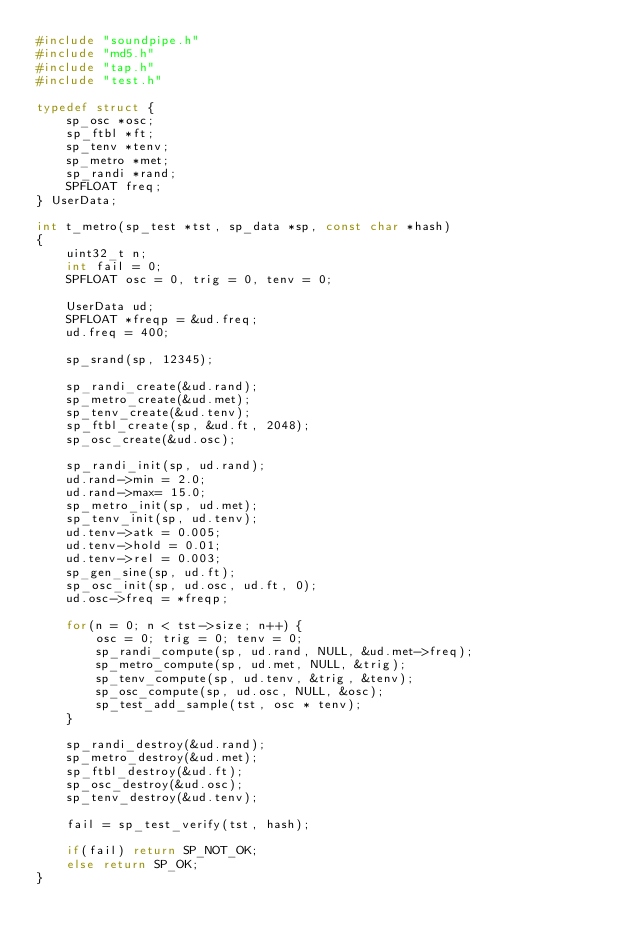<code> <loc_0><loc_0><loc_500><loc_500><_C_>#include "soundpipe.h"
#include "md5.h"
#include "tap.h"
#include "test.h"

typedef struct {
    sp_osc *osc;
    sp_ftbl *ft;
    sp_tenv *tenv;
    sp_metro *met;
    sp_randi *rand;
    SPFLOAT freq;
} UserData;

int t_metro(sp_test *tst, sp_data *sp, const char *hash)
{
    uint32_t n;
    int fail = 0;
    SPFLOAT osc = 0, trig = 0, tenv = 0;

    UserData ud;
    SPFLOAT *freqp = &ud.freq;
    ud.freq = 400;

    sp_srand(sp, 12345);

    sp_randi_create(&ud.rand);
    sp_metro_create(&ud.met);
    sp_tenv_create(&ud.tenv);
    sp_ftbl_create(sp, &ud.ft, 2048);
    sp_osc_create(&ud.osc);

    sp_randi_init(sp, ud.rand);
    ud.rand->min = 2.0;
    ud.rand->max= 15.0;
    sp_metro_init(sp, ud.met);
    sp_tenv_init(sp, ud.tenv);
    ud.tenv->atk = 0.005;
    ud.tenv->hold = 0.01;
    ud.tenv->rel = 0.003;
    sp_gen_sine(sp, ud.ft);
    sp_osc_init(sp, ud.osc, ud.ft, 0);
    ud.osc->freq = *freqp;

    for(n = 0; n < tst->size; n++) {
        osc = 0; trig = 0; tenv = 0;
        sp_randi_compute(sp, ud.rand, NULL, &ud.met->freq);
        sp_metro_compute(sp, ud.met, NULL, &trig);
        sp_tenv_compute(sp, ud.tenv, &trig, &tenv);
        sp_osc_compute(sp, ud.osc, NULL, &osc);
        sp_test_add_sample(tst, osc * tenv);
    }

    sp_randi_destroy(&ud.rand);
    sp_metro_destroy(&ud.met);
    sp_ftbl_destroy(&ud.ft);
    sp_osc_destroy(&ud.osc);
    sp_tenv_destroy(&ud.tenv);

    fail = sp_test_verify(tst, hash);

    if(fail) return SP_NOT_OK;
    else return SP_OK;
}
</code> 